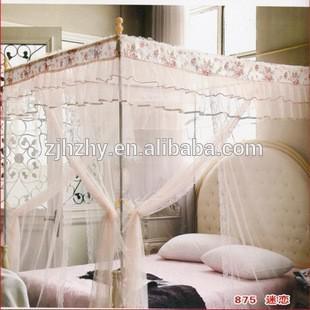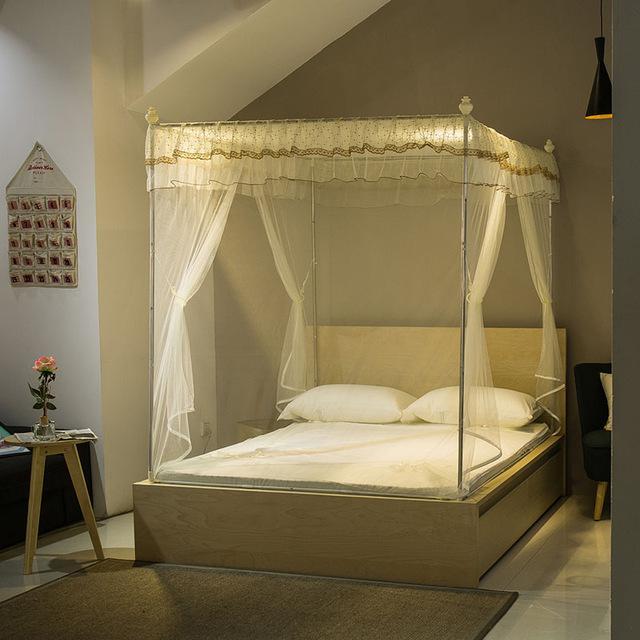The first image is the image on the left, the second image is the image on the right. Analyze the images presented: Is the assertion "At least one image shows a gauzy canopy that drapes a bed from a round shape suspended from the ceiling, and at least one image features a pink canopy draping a bed." valid? Answer yes or no. No. 